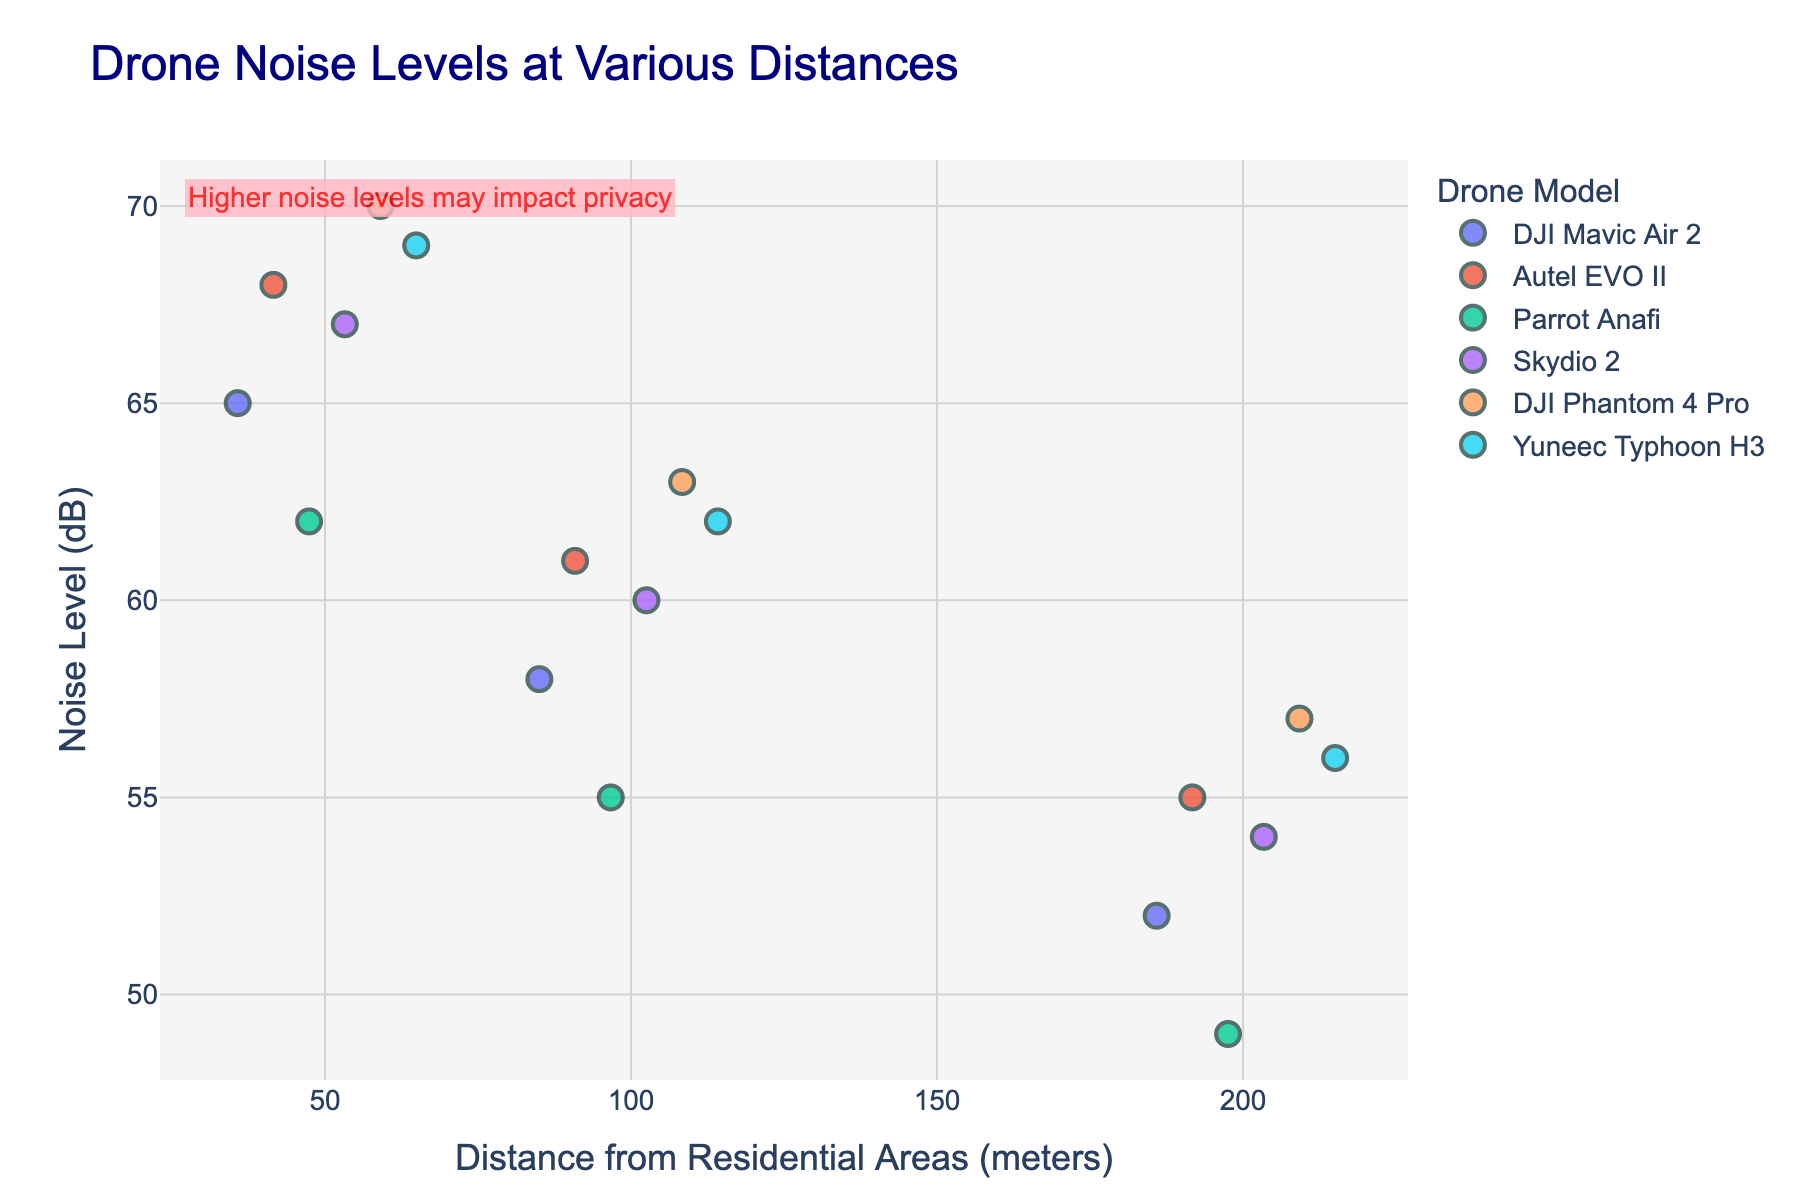What's the title of the figure? The title is the text at the top of the figure, which in this case is "Drone Noise Levels at Various Distances".
Answer: Drone Noise Levels at Various Distances What does the x-axis represent? The x-axis represents the distance from residential areas in meters. This information is found in the label of the x-axis.
Answer: Distance from Residential Areas (meters) Which drone model has the highest noise level at 50 meters? By looking at the points plotted for 50 meters, the highest point belongs to the DJI Phantom 4 Pro with a noise level of 70 dB.
Answer: DJI Phantom 4 Pro How does the noise level of the DJI Mavic Air 2 change as the distance increases from 50 to 200 meters? To determine this, we observe the noise levels of the DJI Mavic Air 2 at distances of 50 meters (65 dB), 100 meters (58 dB), and 200 meters (52 dB). The noise level decreases as the distance increases.
Answer: Decreases Which drone model has the lowest noise level at 200 meters? Observing the points plotted for 200 meters, the Parrot Anafi has the lowest noise level with 49 dB.
Answer: Parrot Anafi Compare the noise levels of the Autel EVO II and Skydio 2 at 100 meters. At 100 meters, Autel EVO II has a noise level of 61 dB, and Skydio 2 has a noise level of 60 dB. So, Autel EVO II is louder by 1 dB.
Answer: Autel EVO II is louder by 1 dB Which drone models have noise levels above 65 dB at 50 meters? At 50 meters, the drone models with noise levels above 65 dB are Autel EVO II (68 dB), Skydio 2 (67 dB), DJI Phantom 4 Pro (70 dB), and Yuneec Typhoon H3 (69 dB).
Answer: Autel EVO II, Skydio 2, DJI Phantom 4 Pro, Yuneec Typhoon H3 What is the overall trend in noise levels for all drones as the distance from residential areas increases? Examining the data points for each drone model at different distances, the overall trend shows that noise levels decrease as the distance from residential areas increases.
Answer: Decreases 